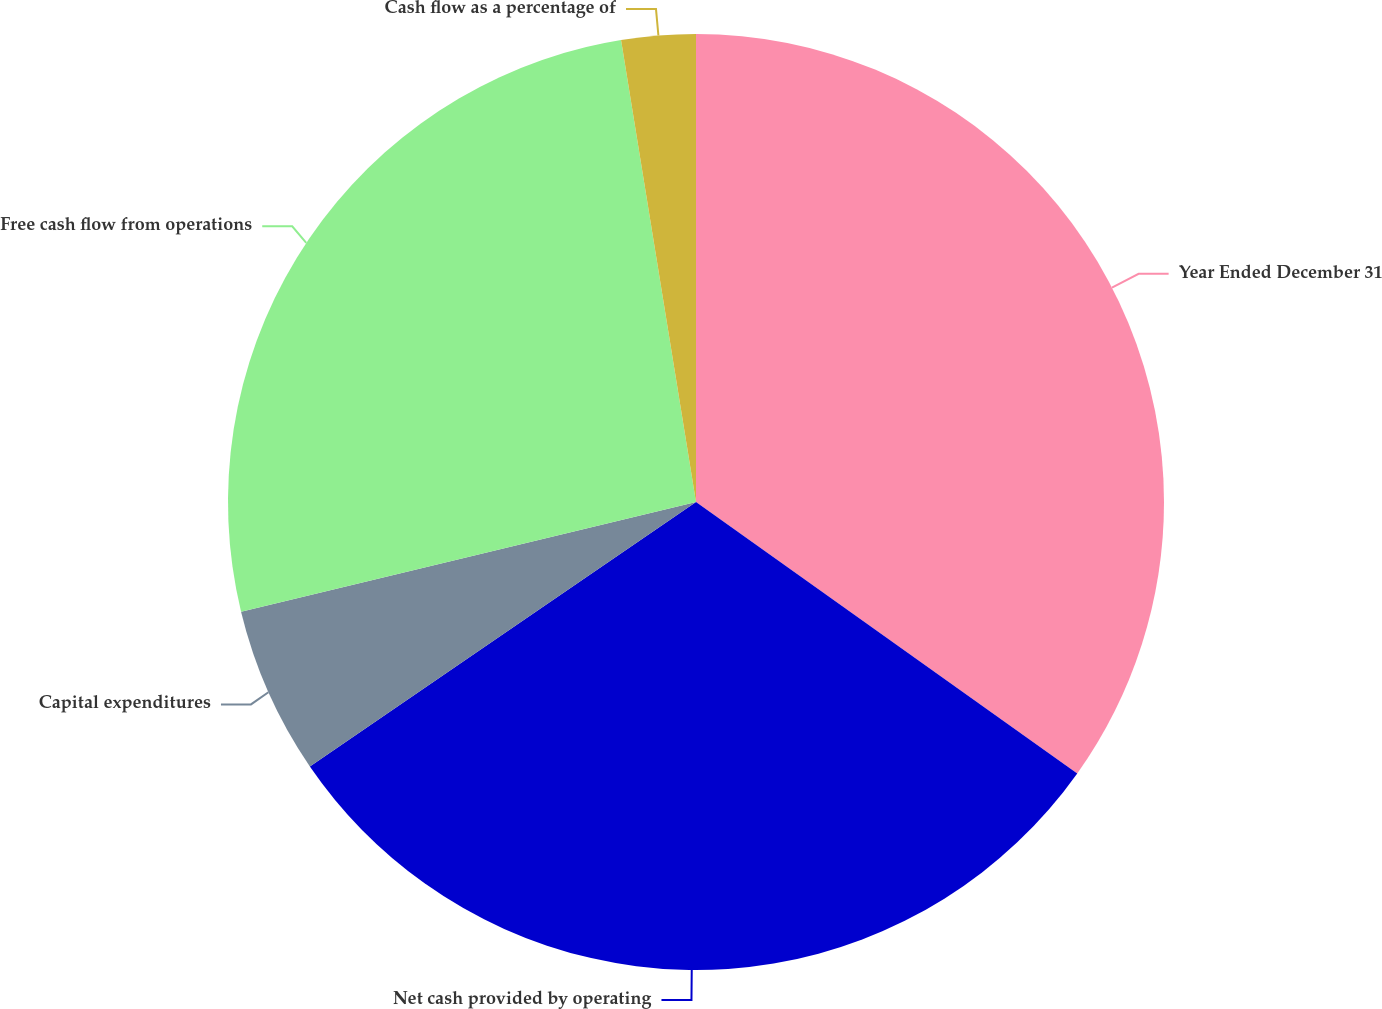<chart> <loc_0><loc_0><loc_500><loc_500><pie_chart><fcel>Year Ended December 31<fcel>Net cash provided by operating<fcel>Capital expenditures<fcel>Free cash flow from operations<fcel>Cash flow as a percentage of<nl><fcel>34.85%<fcel>30.6%<fcel>5.79%<fcel>26.21%<fcel>2.56%<nl></chart> 